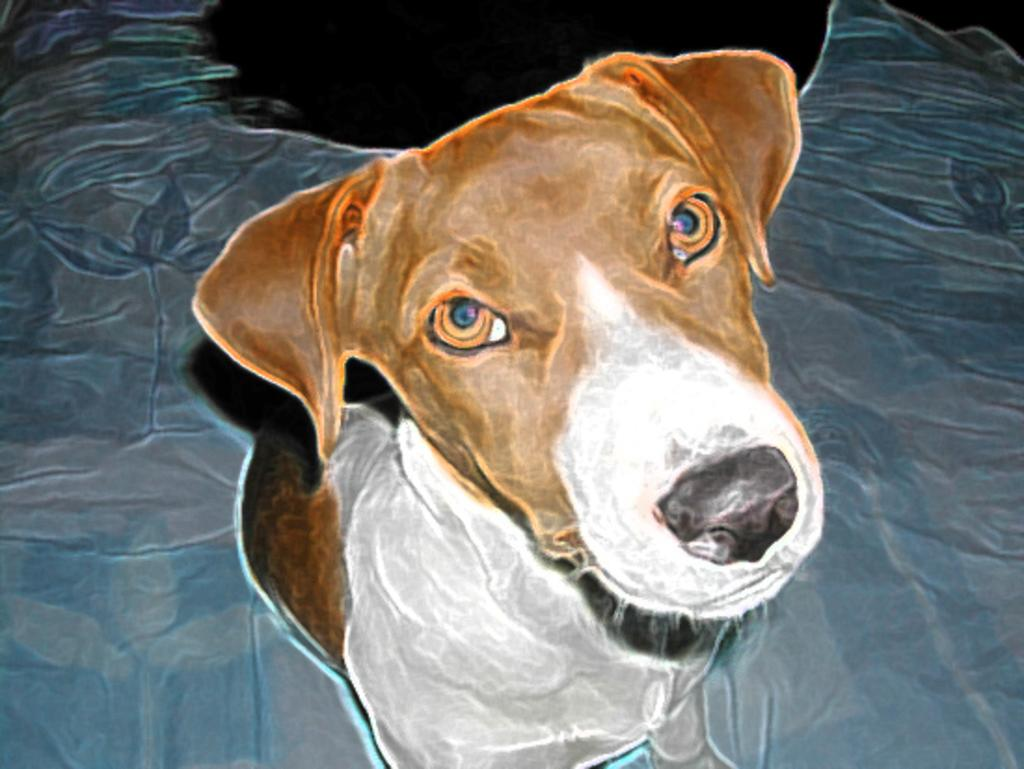What is depicted in the image? There is a painting of a dog in the image. Can you describe the subject of the painting? The painting features a dog as its subject. What type of hospital is shown in the background of the painting? There is no hospital present in the painting; it only features a dog. How many eyes does the ship have in the painting? There is no ship present in the painting; it only features a dog. 